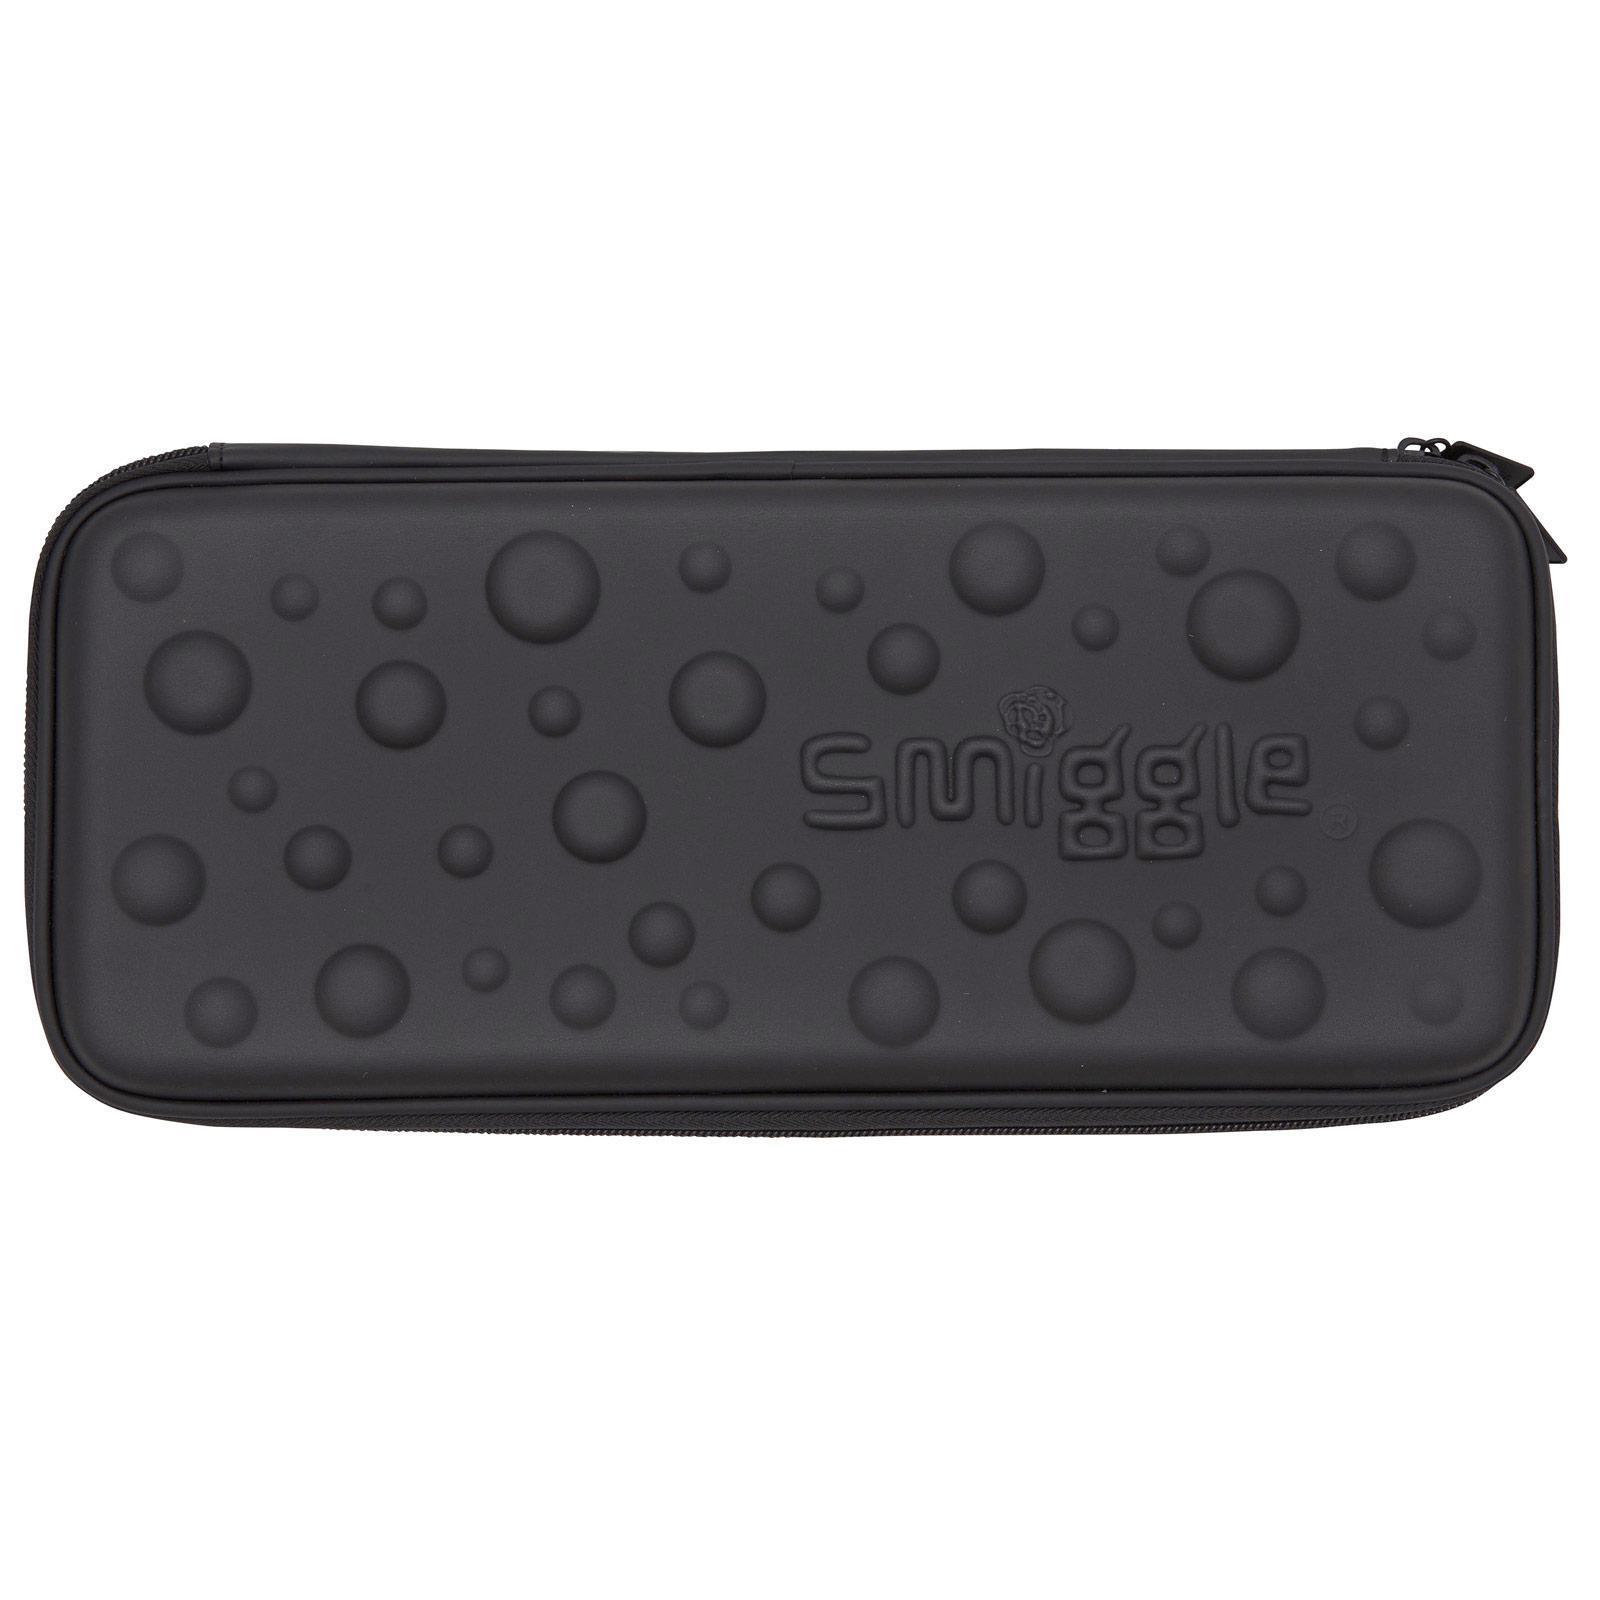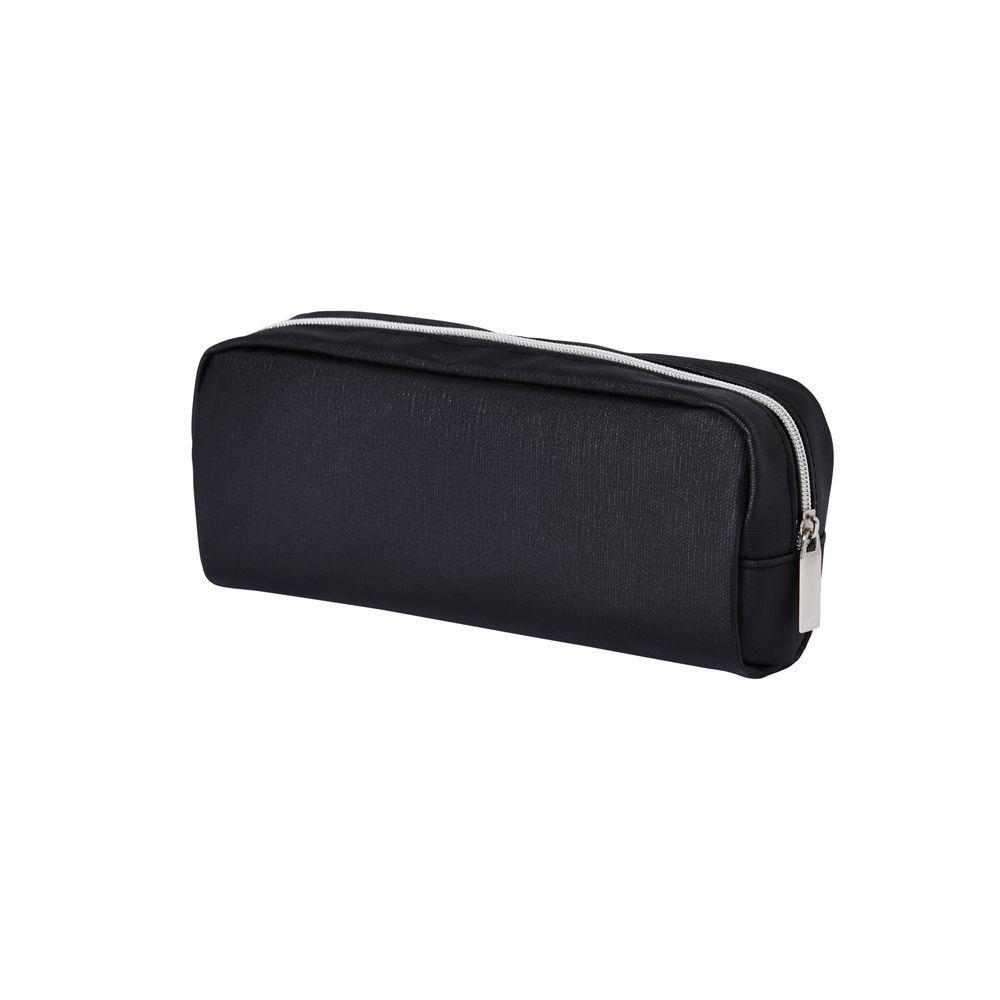The first image is the image on the left, the second image is the image on the right. Considering the images on both sides, is "there is a pencil pouch with raised bumps in varying sizes on it" valid? Answer yes or no. Yes. The first image is the image on the left, the second image is the image on the right. Analyze the images presented: Is the assertion "The black pencil case on the left is closed and has raised dots on its front, and the case on the right is also closed." valid? Answer yes or no. Yes. 